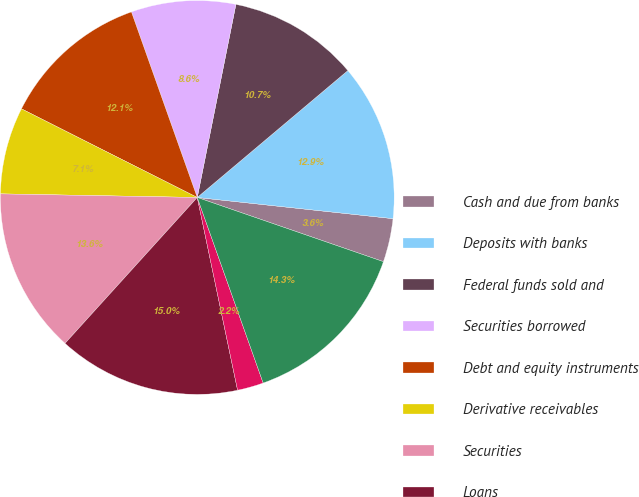Convert chart. <chart><loc_0><loc_0><loc_500><loc_500><pie_chart><fcel>Cash and due from banks<fcel>Deposits with banks<fcel>Federal funds sold and<fcel>Securities borrowed<fcel>Debt and equity instruments<fcel>Derivative receivables<fcel>Securities<fcel>Loans<fcel>Allowance for loan losses<fcel>Loans net of allowance for<nl><fcel>3.57%<fcel>12.86%<fcel>10.71%<fcel>8.57%<fcel>12.14%<fcel>7.14%<fcel>13.57%<fcel>15.0%<fcel>2.15%<fcel>14.28%<nl></chart> 